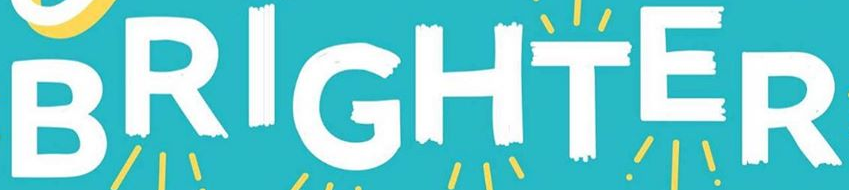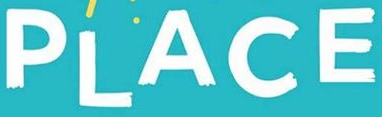Read the text content from these images in order, separated by a semicolon. BRIGHTER; PLACE 